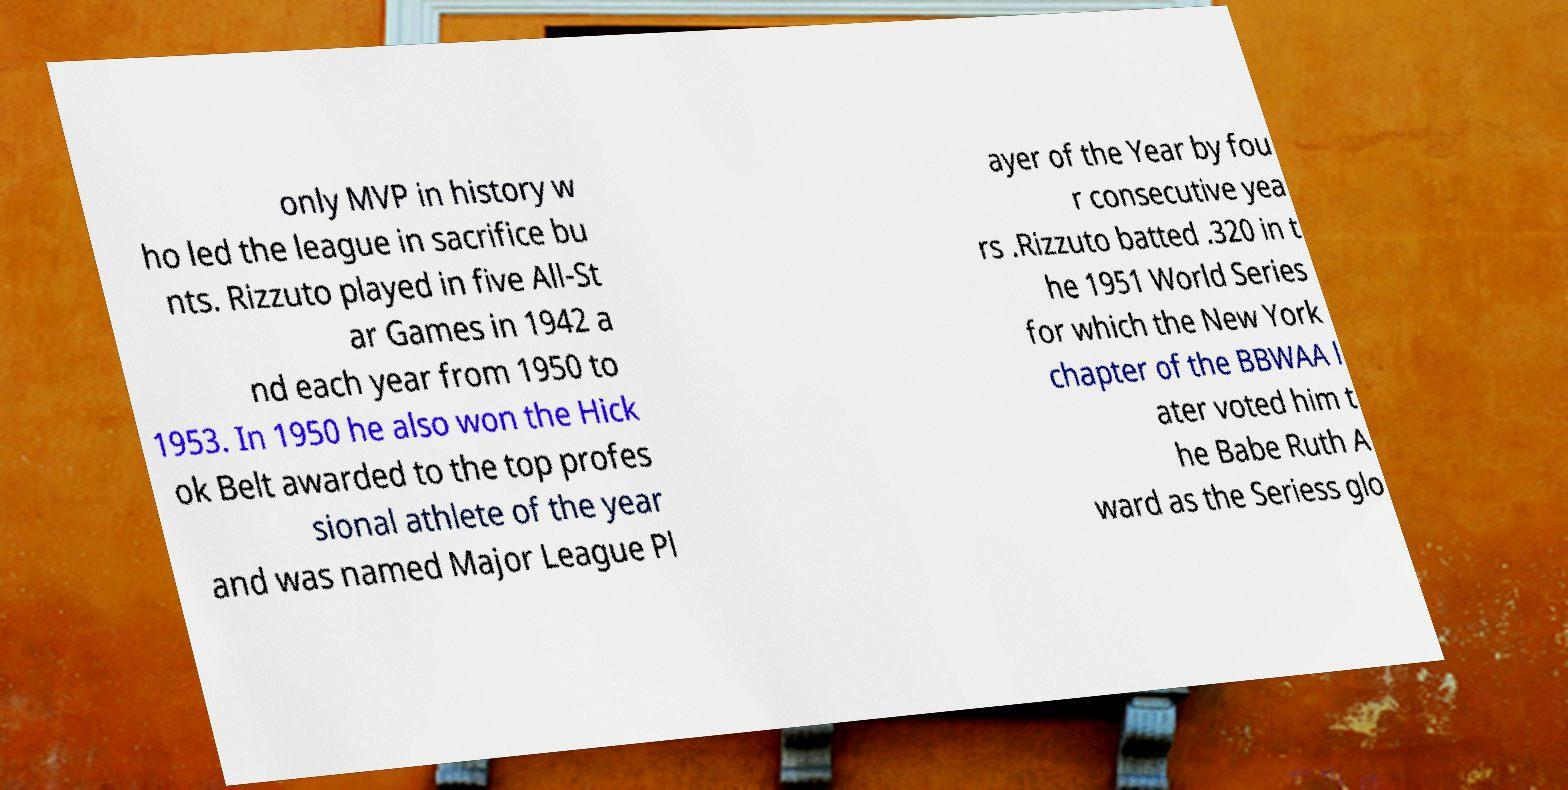Could you extract and type out the text from this image? only MVP in history w ho led the league in sacrifice bu nts. Rizzuto played in five All-St ar Games in 1942 a nd each year from 1950 to 1953. In 1950 he also won the Hick ok Belt awarded to the top profes sional athlete of the year and was named Major League Pl ayer of the Year by fou r consecutive yea rs .Rizzuto batted .320 in t he 1951 World Series for which the New York chapter of the BBWAA l ater voted him t he Babe Ruth A ward as the Seriess glo 